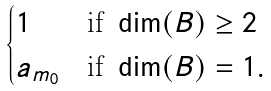Convert formula to latex. <formula><loc_0><loc_0><loc_500><loc_500>\begin{cases} 1 & \text {if} \ \dim ( B ) \geq 2 \\ a _ { m _ { 0 } } & \text {if} \ \dim ( B ) = 1 . \end{cases}</formula> 